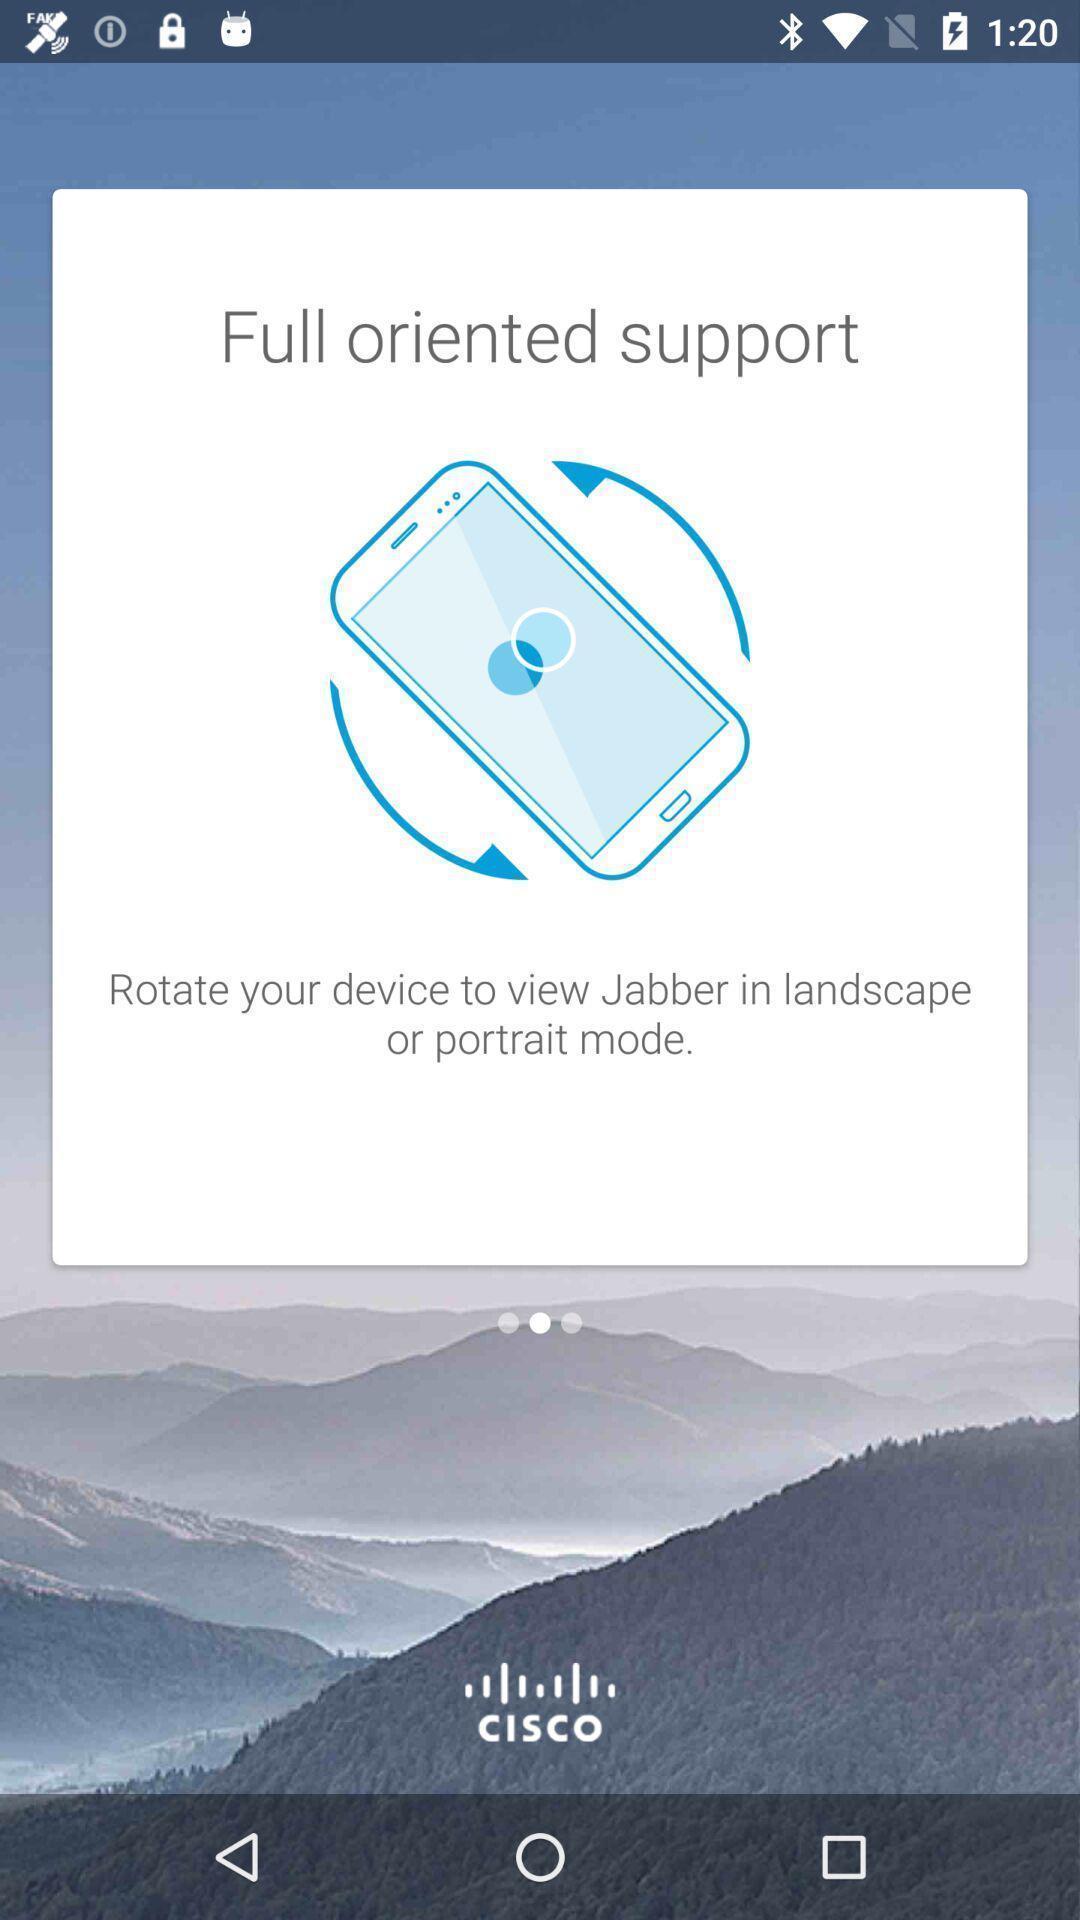Explain what's happening in this screen capture. Page with instruction to view jabber in other mode. 